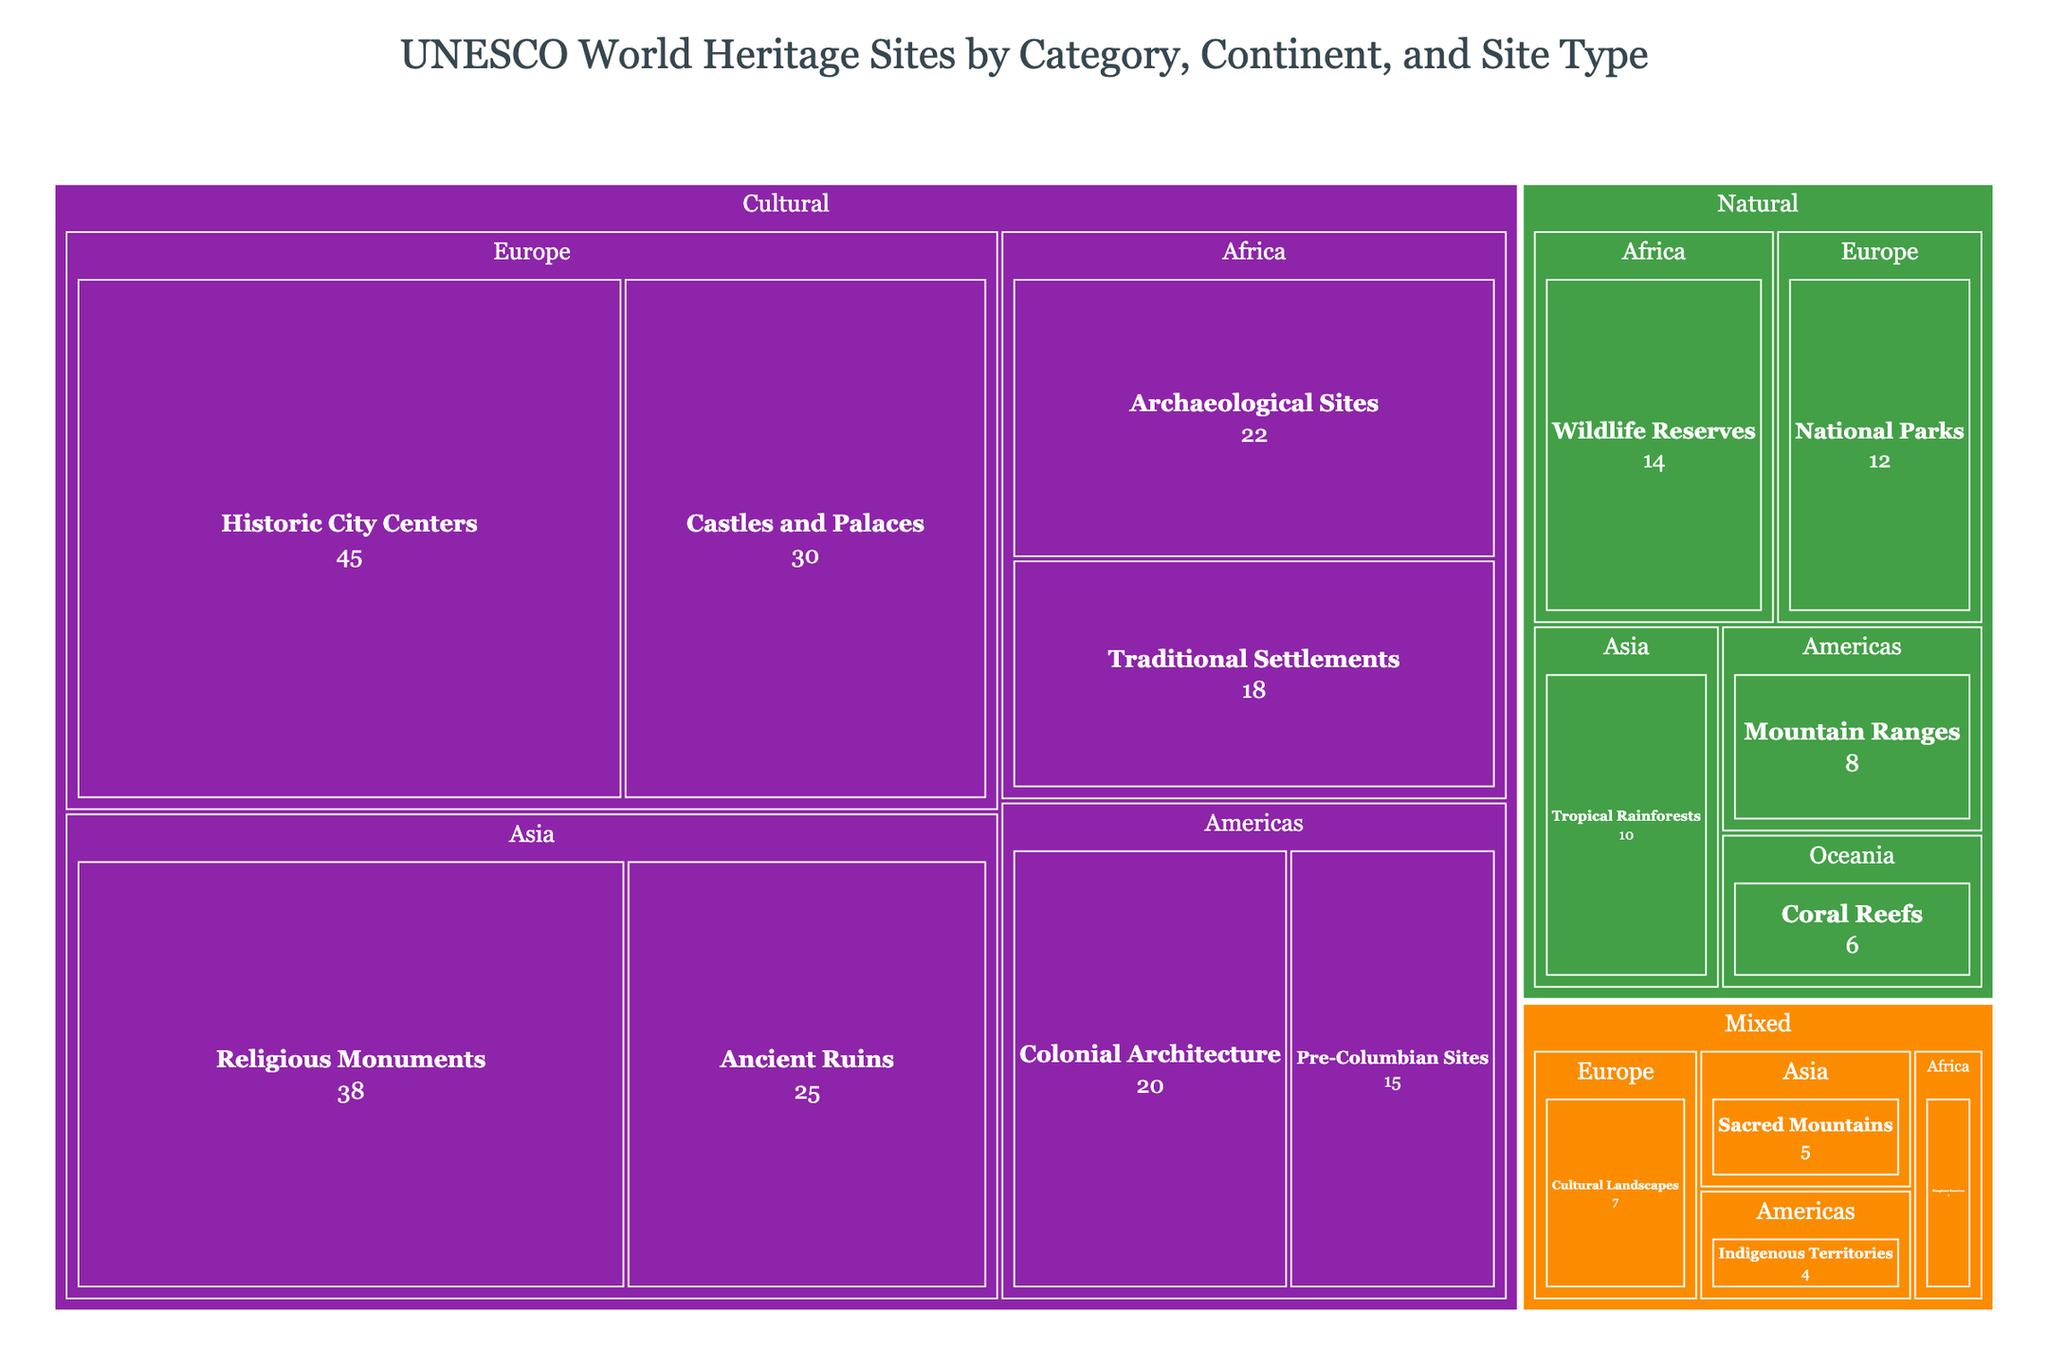What is the title of the treemap? The title is at the top of the treemap, usually in larger and distinctive font, helping to contextualize the data represented.
Answer: UNESCO World Heritage Sites by Category, Continent, and Site Type Which continent has the highest count of Cultural category sites? To determine this, identify the 'Cultural' category and look for the continent with the largest area under it. Europe has the largest rectangular area among the continents in the Cultural category.
Answer: Europe How many Natural sites are there in Asia? Navigate the treemap to identify the Natural category, then locate the section for Asia under this category, and note the count for "Tropical Rainforests".
Answer: 10 Which continent has the least number of sites in the Mixed category? Examine the Mixed category and compare the sizes of the rectangles representing continents. Africa has the smallest rectangle within the Mixed category.
Answer: Africa What is the total count of sites in the Americas across all categories? Sum the counts of the sites in the Americas across the Cultural (20 + 15), Natural (8), and Mixed (4) categories. 20 + 15 + 8 + 4 = 47
Answer: 47 How does the count of Cultural sites in Asia compare to those in Europe? Compare the counts of Cultural sites in Asia (38 + 25 = 63) to those in Europe (45 + 30 = 75). Asia has fewer Cultural sites than Europe.
Answer: Asia has fewer Which category has the fewest overall sites? Compare the areas of the rectangles for all three categories (Cultural, Natural, Mixed) to identify the one with the smallest total area. Mixed has the smallest area overall.
Answer: Mixed What is the difference in count between the largest and smallest site types within the Cultural category? Identify the largest (Historic City Centers with 45) and smallest (Pre-Columbian Sites with 15) site types under Cultural, then subtract the counts. 45 - 15 = 30
Answer: 30 Where would you find Coral Reefs in the treemap, and how many are there? Locate the Natural category, find the section for Oceania, and check the count next to Coral Reefs.
Answer: Oceania, 6 Which site type has the highest count in Africa, and how many are there? Check the counts of different site types in Africa by navigating both Cultural and Natural categories. Archaeological Sites has the highest count at 22.
Answer: Archaeological Sites, 22 